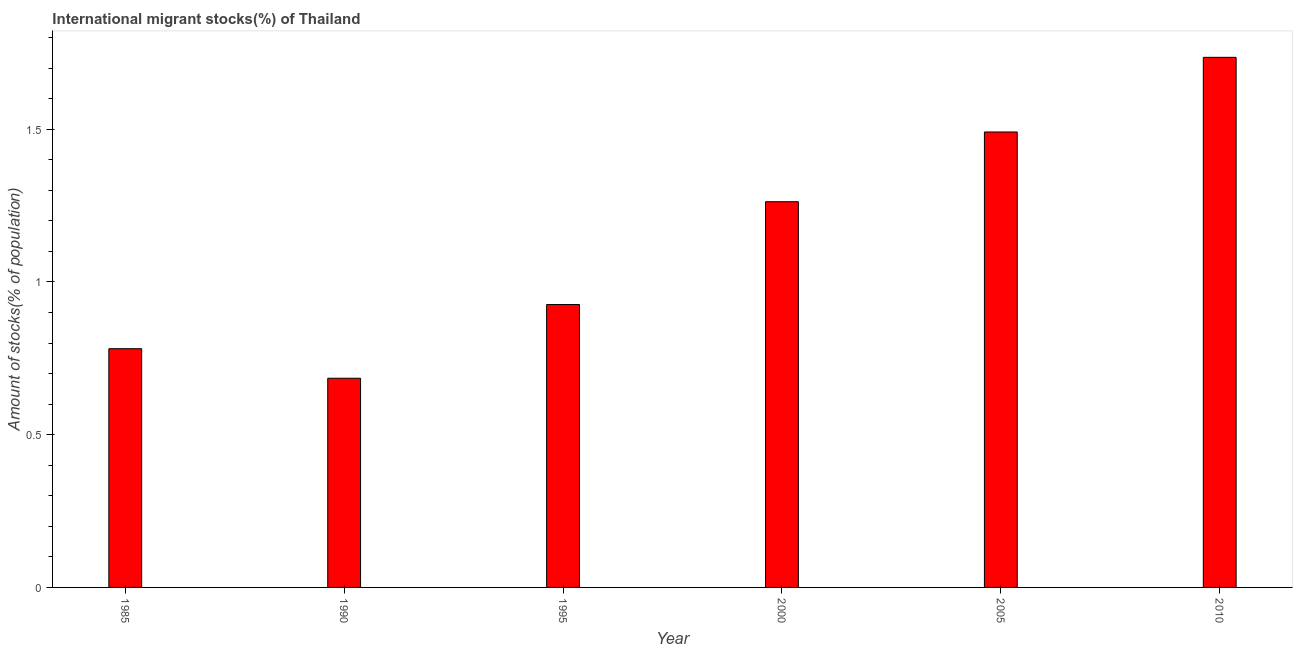Does the graph contain any zero values?
Offer a terse response. No. Does the graph contain grids?
Offer a very short reply. No. What is the title of the graph?
Offer a very short reply. International migrant stocks(%) of Thailand. What is the label or title of the X-axis?
Offer a terse response. Year. What is the label or title of the Y-axis?
Your answer should be very brief. Amount of stocks(% of population). What is the number of international migrant stocks in 1985?
Your answer should be very brief. 0.78. Across all years, what is the maximum number of international migrant stocks?
Your response must be concise. 1.74. Across all years, what is the minimum number of international migrant stocks?
Your response must be concise. 0.68. In which year was the number of international migrant stocks minimum?
Your answer should be compact. 1990. What is the sum of the number of international migrant stocks?
Provide a succinct answer. 6.88. What is the difference between the number of international migrant stocks in 1990 and 2010?
Your answer should be very brief. -1.05. What is the average number of international migrant stocks per year?
Provide a succinct answer. 1.15. What is the median number of international migrant stocks?
Offer a terse response. 1.09. In how many years, is the number of international migrant stocks greater than 0.5 %?
Provide a short and direct response. 6. What is the ratio of the number of international migrant stocks in 2000 to that in 2005?
Provide a succinct answer. 0.85. What is the difference between the highest and the second highest number of international migrant stocks?
Keep it short and to the point. 0.24. Is the sum of the number of international migrant stocks in 1990 and 2010 greater than the maximum number of international migrant stocks across all years?
Your answer should be very brief. Yes. What is the difference between the highest and the lowest number of international migrant stocks?
Keep it short and to the point. 1.05. In how many years, is the number of international migrant stocks greater than the average number of international migrant stocks taken over all years?
Offer a terse response. 3. How many bars are there?
Your response must be concise. 6. How many years are there in the graph?
Provide a succinct answer. 6. Are the values on the major ticks of Y-axis written in scientific E-notation?
Offer a very short reply. No. What is the Amount of stocks(% of population) of 1985?
Your answer should be compact. 0.78. What is the Amount of stocks(% of population) of 1990?
Offer a terse response. 0.68. What is the Amount of stocks(% of population) of 1995?
Give a very brief answer. 0.93. What is the Amount of stocks(% of population) of 2000?
Your response must be concise. 1.26. What is the Amount of stocks(% of population) of 2005?
Offer a terse response. 1.49. What is the Amount of stocks(% of population) of 2010?
Your answer should be very brief. 1.74. What is the difference between the Amount of stocks(% of population) in 1985 and 1990?
Provide a succinct answer. 0.1. What is the difference between the Amount of stocks(% of population) in 1985 and 1995?
Make the answer very short. -0.14. What is the difference between the Amount of stocks(% of population) in 1985 and 2000?
Your answer should be very brief. -0.48. What is the difference between the Amount of stocks(% of population) in 1985 and 2005?
Your answer should be compact. -0.71. What is the difference between the Amount of stocks(% of population) in 1985 and 2010?
Ensure brevity in your answer.  -0.95. What is the difference between the Amount of stocks(% of population) in 1990 and 1995?
Your response must be concise. -0.24. What is the difference between the Amount of stocks(% of population) in 1990 and 2000?
Offer a terse response. -0.58. What is the difference between the Amount of stocks(% of population) in 1990 and 2005?
Provide a short and direct response. -0.81. What is the difference between the Amount of stocks(% of population) in 1990 and 2010?
Offer a terse response. -1.05. What is the difference between the Amount of stocks(% of population) in 1995 and 2000?
Provide a succinct answer. -0.34. What is the difference between the Amount of stocks(% of population) in 1995 and 2005?
Your answer should be very brief. -0.56. What is the difference between the Amount of stocks(% of population) in 1995 and 2010?
Give a very brief answer. -0.81. What is the difference between the Amount of stocks(% of population) in 2000 and 2005?
Provide a succinct answer. -0.23. What is the difference between the Amount of stocks(% of population) in 2000 and 2010?
Your answer should be very brief. -0.47. What is the difference between the Amount of stocks(% of population) in 2005 and 2010?
Provide a succinct answer. -0.24. What is the ratio of the Amount of stocks(% of population) in 1985 to that in 1990?
Your answer should be compact. 1.14. What is the ratio of the Amount of stocks(% of population) in 1985 to that in 1995?
Offer a terse response. 0.84. What is the ratio of the Amount of stocks(% of population) in 1985 to that in 2000?
Offer a very short reply. 0.62. What is the ratio of the Amount of stocks(% of population) in 1985 to that in 2005?
Your response must be concise. 0.52. What is the ratio of the Amount of stocks(% of population) in 1985 to that in 2010?
Your answer should be very brief. 0.45. What is the ratio of the Amount of stocks(% of population) in 1990 to that in 1995?
Offer a terse response. 0.74. What is the ratio of the Amount of stocks(% of population) in 1990 to that in 2000?
Offer a very short reply. 0.54. What is the ratio of the Amount of stocks(% of population) in 1990 to that in 2005?
Your answer should be very brief. 0.46. What is the ratio of the Amount of stocks(% of population) in 1990 to that in 2010?
Your answer should be compact. 0.4. What is the ratio of the Amount of stocks(% of population) in 1995 to that in 2000?
Provide a succinct answer. 0.73. What is the ratio of the Amount of stocks(% of population) in 1995 to that in 2005?
Your response must be concise. 0.62. What is the ratio of the Amount of stocks(% of population) in 1995 to that in 2010?
Ensure brevity in your answer.  0.53. What is the ratio of the Amount of stocks(% of population) in 2000 to that in 2005?
Provide a short and direct response. 0.85. What is the ratio of the Amount of stocks(% of population) in 2000 to that in 2010?
Make the answer very short. 0.73. What is the ratio of the Amount of stocks(% of population) in 2005 to that in 2010?
Your answer should be compact. 0.86. 